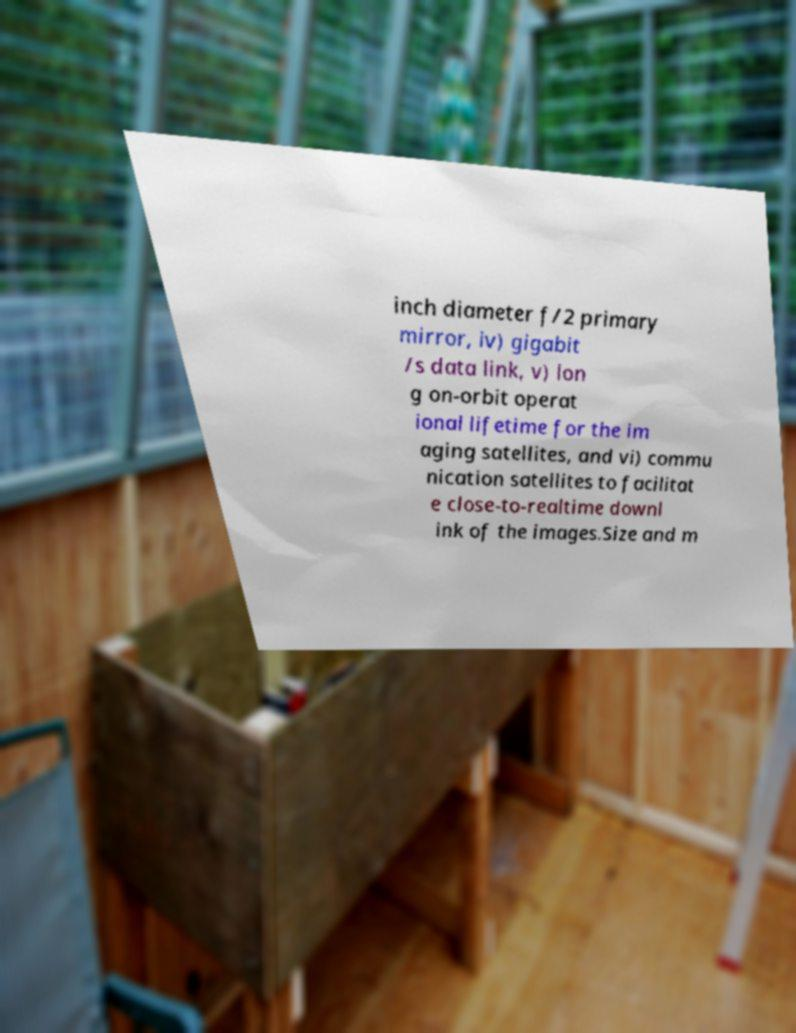Can you read and provide the text displayed in the image?This photo seems to have some interesting text. Can you extract and type it out for me? inch diameter f/2 primary mirror, iv) gigabit /s data link, v) lon g on-orbit operat ional lifetime for the im aging satellites, and vi) commu nication satellites to facilitat e close-to-realtime downl ink of the images.Size and m 